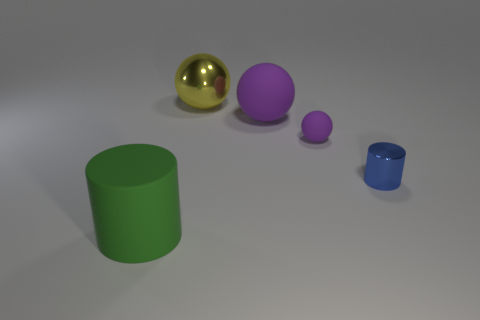How big is the metal cylinder?
Provide a short and direct response. Small. There is a cylinder that is to the right of the large yellow sphere that is on the left side of the cylinder behind the big green thing; what is its material?
Ensure brevity in your answer.  Metal. How many other things are there of the same color as the small matte ball?
Make the answer very short. 1. How many purple things are metal cylinders or large matte spheres?
Keep it short and to the point. 1. There is a cylinder that is behind the green matte cylinder; what is it made of?
Your answer should be compact. Metal. Are the large object on the left side of the yellow ball and the small ball made of the same material?
Your answer should be very brief. Yes. The small purple object is what shape?
Your answer should be very brief. Sphere. How many tiny shiny cylinders are to the left of the purple rubber thing right of the purple ball behind the tiny purple object?
Your answer should be compact. 0. What number of other objects are there of the same material as the yellow object?
Offer a terse response. 1. What is the material of the purple thing that is the same size as the metallic sphere?
Make the answer very short. Rubber. 